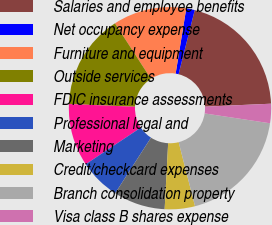Convert chart. <chart><loc_0><loc_0><loc_500><loc_500><pie_chart><fcel>Salaries and employee benefits<fcel>Net occupancy expense<fcel>Furniture and equipment<fcel>Outside services<fcel>FDIC insurance assessments<fcel>Professional legal and<fcel>Marketing<fcel>Credit/checkcard expenses<fcel>Branch consolidation property<fcel>Visa class B shares expense<nl><fcel>20.36%<fcel>1.36%<fcel>11.73%<fcel>15.18%<fcel>10.0%<fcel>6.55%<fcel>8.27%<fcel>4.82%<fcel>18.64%<fcel>3.09%<nl></chart> 